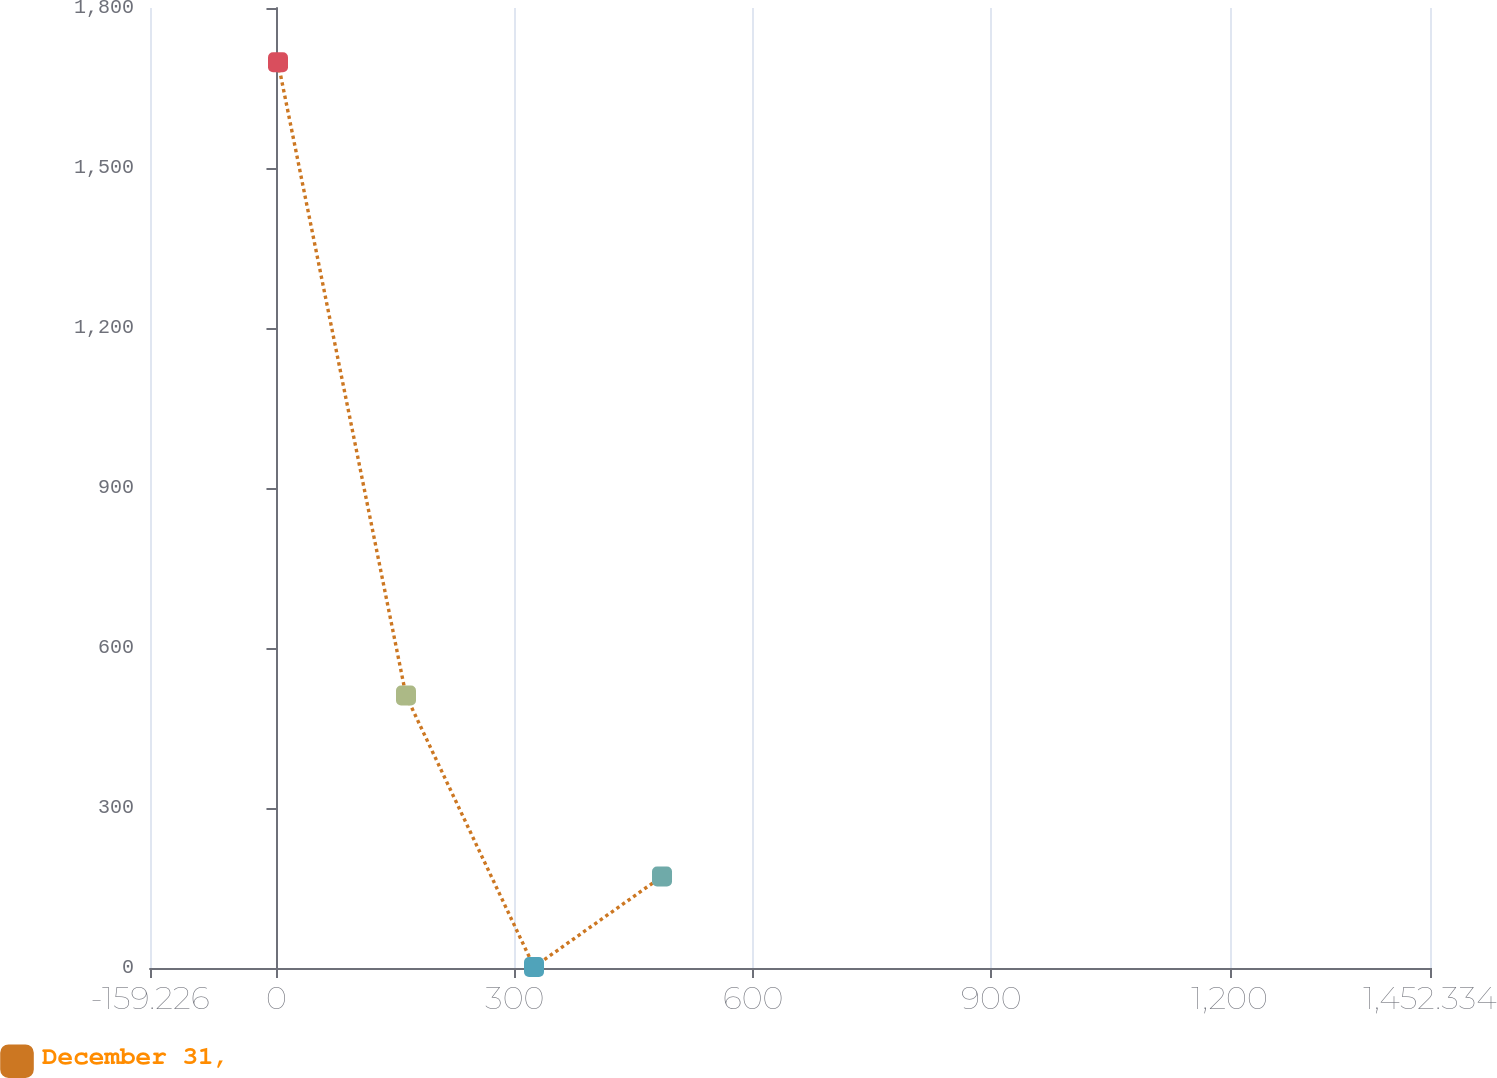<chart> <loc_0><loc_0><loc_500><loc_500><line_chart><ecel><fcel>December 31,<nl><fcel>1.93<fcel>1698.18<nl><fcel>163.09<fcel>510.85<nl><fcel>324.25<fcel>1.99<nl><fcel>485.41<fcel>171.61<nl><fcel>1613.49<fcel>341.23<nl></chart> 